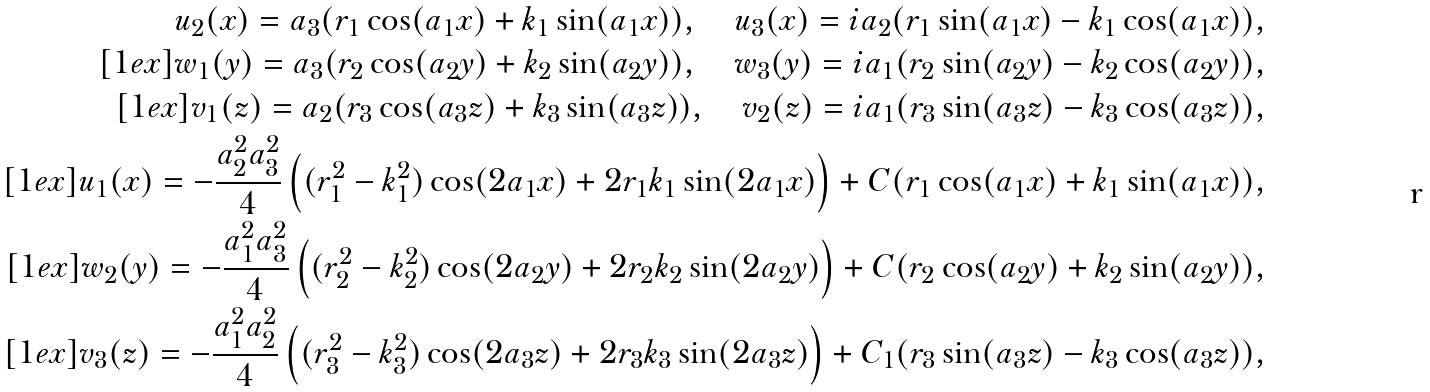<formula> <loc_0><loc_0><loc_500><loc_500>u _ { 2 } ( x ) = a _ { 3 } ( r _ { 1 } \cos ( a _ { 1 } x ) + k _ { 1 } \sin ( a _ { 1 } x ) ) , \quad u _ { 3 } ( x ) = i a _ { 2 } ( r _ { 1 } \sin ( a _ { 1 } x ) - k _ { 1 } \cos ( a _ { 1 } x ) ) , \\ [ 1 e x ] w _ { 1 } ( y ) = a _ { 3 } ( r _ { 2 } \cos ( a _ { 2 } y ) + k _ { 2 } \sin ( a _ { 2 } y ) ) , \quad w _ { 3 } ( y ) = i a _ { 1 } ( r _ { 2 } \sin ( a _ { 2 } y ) - k _ { 2 } \cos ( a _ { 2 } y ) ) , \\ [ 1 e x ] v _ { 1 } ( z ) = a _ { 2 } ( r _ { 3 } \cos ( a _ { 3 } z ) + k _ { 3 } \sin ( a _ { 3 } z ) ) , \quad v _ { 2 } ( z ) = i a _ { 1 } ( r _ { 3 } \sin ( a _ { 3 } z ) - k _ { 3 } \cos ( a _ { 3 } z ) ) , \\ [ 1 e x ] u _ { 1 } ( x ) = - \frac { a _ { 2 } ^ { 2 } a _ { 3 } ^ { 2 } } 4 \left ( ( r _ { 1 } ^ { 2 } - k _ { 1 } ^ { 2 } ) \cos ( 2 a _ { 1 } x ) + 2 r _ { 1 } k _ { 1 } \sin ( 2 a _ { 1 } x ) \right ) + C ( r _ { 1 } \cos ( a _ { 1 } x ) + k _ { 1 } \sin ( a _ { 1 } x ) ) , \\ [ 1 e x ] w _ { 2 } ( y ) = - \frac { a _ { 1 } ^ { 2 } a _ { 3 } ^ { 2 } } 4 \left ( ( r _ { 2 } ^ { 2 } - k _ { 2 } ^ { 2 } ) \cos ( 2 a _ { 2 } y ) + 2 r _ { 2 } k _ { 2 } \sin ( 2 a _ { 2 } y ) \right ) + C ( r _ { 2 } \cos ( a _ { 2 } y ) + k _ { 2 } \sin ( a _ { 2 } y ) ) , \\ [ 1 e x ] v _ { 3 } ( z ) = - \frac { a _ { 1 } ^ { 2 } a _ { 2 } ^ { 2 } } 4 \left ( ( r _ { 3 } ^ { 2 } - k _ { 3 } ^ { 2 } ) \cos ( 2 a _ { 3 } z ) + 2 r _ { 3 } k _ { 3 } \sin ( 2 a _ { 3 } z ) \right ) + C _ { 1 } ( r _ { 3 } \sin ( a _ { 3 } z ) - k _ { 3 } \cos ( a _ { 3 } z ) ) ,</formula> 